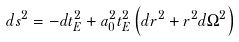<formula> <loc_0><loc_0><loc_500><loc_500>d s ^ { 2 } = - d t _ { E } ^ { 2 } + a _ { 0 } ^ { 2 } t _ { E } ^ { 2 } \left ( d r ^ { 2 } + r ^ { 2 } d \Omega ^ { 2 } \right )</formula> 